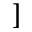<formula> <loc_0><loc_0><loc_500><loc_500>]</formula> 